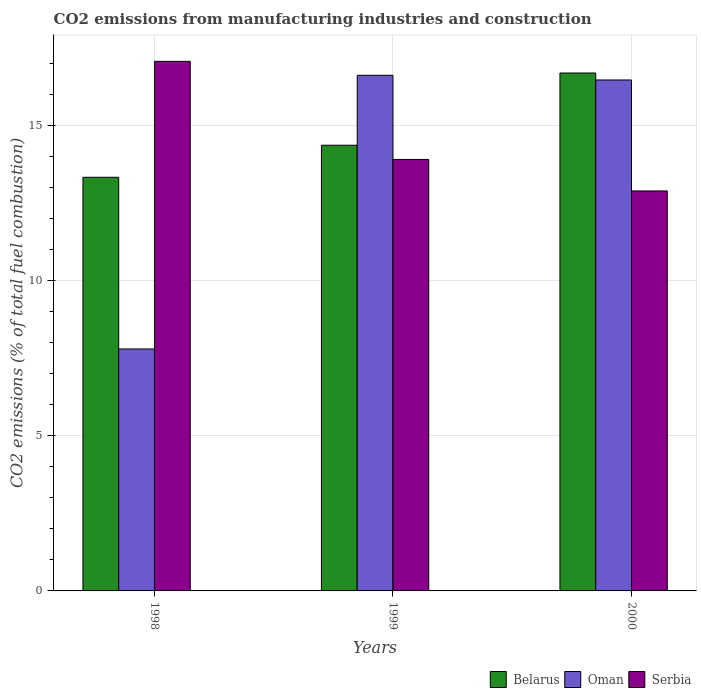How many groups of bars are there?
Provide a short and direct response. 3. Are the number of bars per tick equal to the number of legend labels?
Your answer should be very brief. Yes. How many bars are there on the 1st tick from the right?
Your response must be concise. 3. What is the label of the 2nd group of bars from the left?
Your answer should be compact. 1999. In how many cases, is the number of bars for a given year not equal to the number of legend labels?
Your response must be concise. 0. What is the amount of CO2 emitted in Serbia in 1998?
Provide a succinct answer. 17.07. Across all years, what is the maximum amount of CO2 emitted in Belarus?
Ensure brevity in your answer.  16.69. Across all years, what is the minimum amount of CO2 emitted in Oman?
Provide a short and direct response. 7.8. In which year was the amount of CO2 emitted in Oman maximum?
Provide a short and direct response. 1999. What is the total amount of CO2 emitted in Serbia in the graph?
Your response must be concise. 43.87. What is the difference between the amount of CO2 emitted in Belarus in 1998 and that in 1999?
Your response must be concise. -1.03. What is the difference between the amount of CO2 emitted in Oman in 1998 and the amount of CO2 emitted in Belarus in 1999?
Your response must be concise. -6.57. What is the average amount of CO2 emitted in Oman per year?
Your answer should be very brief. 13.63. In the year 1998, what is the difference between the amount of CO2 emitted in Belarus and amount of CO2 emitted in Serbia?
Offer a terse response. -3.74. What is the ratio of the amount of CO2 emitted in Serbia in 1998 to that in 2000?
Your response must be concise. 1.32. Is the amount of CO2 emitted in Serbia in 1998 less than that in 1999?
Your answer should be compact. No. What is the difference between the highest and the second highest amount of CO2 emitted in Belarus?
Offer a very short reply. 2.33. What is the difference between the highest and the lowest amount of CO2 emitted in Oman?
Offer a terse response. 8.82. Is the sum of the amount of CO2 emitted in Serbia in 1998 and 2000 greater than the maximum amount of CO2 emitted in Oman across all years?
Keep it short and to the point. Yes. What does the 2nd bar from the left in 1998 represents?
Your answer should be very brief. Oman. What does the 3rd bar from the right in 1999 represents?
Provide a succinct answer. Belarus. Is it the case that in every year, the sum of the amount of CO2 emitted in Serbia and amount of CO2 emitted in Oman is greater than the amount of CO2 emitted in Belarus?
Offer a terse response. Yes. How many bars are there?
Keep it short and to the point. 9. How many years are there in the graph?
Give a very brief answer. 3. Are the values on the major ticks of Y-axis written in scientific E-notation?
Offer a terse response. No. Does the graph contain any zero values?
Offer a very short reply. No. Where does the legend appear in the graph?
Keep it short and to the point. Bottom right. How many legend labels are there?
Offer a very short reply. 3. What is the title of the graph?
Give a very brief answer. CO2 emissions from manufacturing industries and construction. What is the label or title of the X-axis?
Ensure brevity in your answer.  Years. What is the label or title of the Y-axis?
Your answer should be very brief. CO2 emissions (% of total fuel combustion). What is the CO2 emissions (% of total fuel combustion) in Belarus in 1998?
Make the answer very short. 13.33. What is the CO2 emissions (% of total fuel combustion) in Oman in 1998?
Offer a terse response. 7.8. What is the CO2 emissions (% of total fuel combustion) of Serbia in 1998?
Offer a terse response. 17.07. What is the CO2 emissions (% of total fuel combustion) of Belarus in 1999?
Your answer should be very brief. 14.36. What is the CO2 emissions (% of total fuel combustion) of Oman in 1999?
Make the answer very short. 16.62. What is the CO2 emissions (% of total fuel combustion) of Serbia in 1999?
Your answer should be very brief. 13.91. What is the CO2 emissions (% of total fuel combustion) in Belarus in 2000?
Your answer should be very brief. 16.69. What is the CO2 emissions (% of total fuel combustion) of Oman in 2000?
Your answer should be very brief. 16.47. What is the CO2 emissions (% of total fuel combustion) of Serbia in 2000?
Provide a succinct answer. 12.89. Across all years, what is the maximum CO2 emissions (% of total fuel combustion) of Belarus?
Provide a succinct answer. 16.69. Across all years, what is the maximum CO2 emissions (% of total fuel combustion) in Oman?
Your answer should be very brief. 16.62. Across all years, what is the maximum CO2 emissions (% of total fuel combustion) in Serbia?
Give a very brief answer. 17.07. Across all years, what is the minimum CO2 emissions (% of total fuel combustion) in Belarus?
Your answer should be very brief. 13.33. Across all years, what is the minimum CO2 emissions (% of total fuel combustion) in Oman?
Provide a succinct answer. 7.8. Across all years, what is the minimum CO2 emissions (% of total fuel combustion) of Serbia?
Offer a very short reply. 12.89. What is the total CO2 emissions (% of total fuel combustion) of Belarus in the graph?
Your answer should be very brief. 44.39. What is the total CO2 emissions (% of total fuel combustion) in Oman in the graph?
Offer a terse response. 40.88. What is the total CO2 emissions (% of total fuel combustion) in Serbia in the graph?
Offer a very short reply. 43.87. What is the difference between the CO2 emissions (% of total fuel combustion) in Belarus in 1998 and that in 1999?
Your answer should be very brief. -1.03. What is the difference between the CO2 emissions (% of total fuel combustion) of Oman in 1998 and that in 1999?
Ensure brevity in your answer.  -8.82. What is the difference between the CO2 emissions (% of total fuel combustion) of Serbia in 1998 and that in 1999?
Your answer should be very brief. 3.16. What is the difference between the CO2 emissions (% of total fuel combustion) in Belarus in 1998 and that in 2000?
Provide a short and direct response. -3.36. What is the difference between the CO2 emissions (% of total fuel combustion) in Oman in 1998 and that in 2000?
Offer a very short reply. -8.67. What is the difference between the CO2 emissions (% of total fuel combustion) of Serbia in 1998 and that in 2000?
Your answer should be compact. 4.18. What is the difference between the CO2 emissions (% of total fuel combustion) in Belarus in 1999 and that in 2000?
Ensure brevity in your answer.  -2.33. What is the difference between the CO2 emissions (% of total fuel combustion) in Oman in 1999 and that in 2000?
Give a very brief answer. 0.15. What is the difference between the CO2 emissions (% of total fuel combustion) in Serbia in 1999 and that in 2000?
Provide a succinct answer. 1.02. What is the difference between the CO2 emissions (% of total fuel combustion) of Belarus in 1998 and the CO2 emissions (% of total fuel combustion) of Oman in 1999?
Provide a succinct answer. -3.29. What is the difference between the CO2 emissions (% of total fuel combustion) of Belarus in 1998 and the CO2 emissions (% of total fuel combustion) of Serbia in 1999?
Your answer should be very brief. -0.58. What is the difference between the CO2 emissions (% of total fuel combustion) in Oman in 1998 and the CO2 emissions (% of total fuel combustion) in Serbia in 1999?
Give a very brief answer. -6.11. What is the difference between the CO2 emissions (% of total fuel combustion) of Belarus in 1998 and the CO2 emissions (% of total fuel combustion) of Oman in 2000?
Offer a very short reply. -3.14. What is the difference between the CO2 emissions (% of total fuel combustion) in Belarus in 1998 and the CO2 emissions (% of total fuel combustion) in Serbia in 2000?
Ensure brevity in your answer.  0.44. What is the difference between the CO2 emissions (% of total fuel combustion) in Oman in 1998 and the CO2 emissions (% of total fuel combustion) in Serbia in 2000?
Offer a terse response. -5.09. What is the difference between the CO2 emissions (% of total fuel combustion) of Belarus in 1999 and the CO2 emissions (% of total fuel combustion) of Oman in 2000?
Offer a terse response. -2.1. What is the difference between the CO2 emissions (% of total fuel combustion) in Belarus in 1999 and the CO2 emissions (% of total fuel combustion) in Serbia in 2000?
Provide a short and direct response. 1.47. What is the difference between the CO2 emissions (% of total fuel combustion) in Oman in 1999 and the CO2 emissions (% of total fuel combustion) in Serbia in 2000?
Your answer should be compact. 3.73. What is the average CO2 emissions (% of total fuel combustion) in Belarus per year?
Offer a terse response. 14.8. What is the average CO2 emissions (% of total fuel combustion) of Oman per year?
Ensure brevity in your answer.  13.63. What is the average CO2 emissions (% of total fuel combustion) of Serbia per year?
Your answer should be compact. 14.62. In the year 1998, what is the difference between the CO2 emissions (% of total fuel combustion) in Belarus and CO2 emissions (% of total fuel combustion) in Oman?
Ensure brevity in your answer.  5.53. In the year 1998, what is the difference between the CO2 emissions (% of total fuel combustion) in Belarus and CO2 emissions (% of total fuel combustion) in Serbia?
Ensure brevity in your answer.  -3.74. In the year 1998, what is the difference between the CO2 emissions (% of total fuel combustion) in Oman and CO2 emissions (% of total fuel combustion) in Serbia?
Your response must be concise. -9.27. In the year 1999, what is the difference between the CO2 emissions (% of total fuel combustion) in Belarus and CO2 emissions (% of total fuel combustion) in Oman?
Provide a succinct answer. -2.25. In the year 1999, what is the difference between the CO2 emissions (% of total fuel combustion) in Belarus and CO2 emissions (% of total fuel combustion) in Serbia?
Offer a very short reply. 0.46. In the year 1999, what is the difference between the CO2 emissions (% of total fuel combustion) in Oman and CO2 emissions (% of total fuel combustion) in Serbia?
Offer a very short reply. 2.71. In the year 2000, what is the difference between the CO2 emissions (% of total fuel combustion) of Belarus and CO2 emissions (% of total fuel combustion) of Oman?
Your answer should be compact. 0.22. In the year 2000, what is the difference between the CO2 emissions (% of total fuel combustion) in Belarus and CO2 emissions (% of total fuel combustion) in Serbia?
Give a very brief answer. 3.8. In the year 2000, what is the difference between the CO2 emissions (% of total fuel combustion) in Oman and CO2 emissions (% of total fuel combustion) in Serbia?
Give a very brief answer. 3.58. What is the ratio of the CO2 emissions (% of total fuel combustion) of Belarus in 1998 to that in 1999?
Give a very brief answer. 0.93. What is the ratio of the CO2 emissions (% of total fuel combustion) in Oman in 1998 to that in 1999?
Provide a succinct answer. 0.47. What is the ratio of the CO2 emissions (% of total fuel combustion) in Serbia in 1998 to that in 1999?
Your answer should be very brief. 1.23. What is the ratio of the CO2 emissions (% of total fuel combustion) in Belarus in 1998 to that in 2000?
Offer a terse response. 0.8. What is the ratio of the CO2 emissions (% of total fuel combustion) in Oman in 1998 to that in 2000?
Your response must be concise. 0.47. What is the ratio of the CO2 emissions (% of total fuel combustion) of Serbia in 1998 to that in 2000?
Ensure brevity in your answer.  1.32. What is the ratio of the CO2 emissions (% of total fuel combustion) in Belarus in 1999 to that in 2000?
Offer a terse response. 0.86. What is the ratio of the CO2 emissions (% of total fuel combustion) of Oman in 1999 to that in 2000?
Your answer should be compact. 1.01. What is the ratio of the CO2 emissions (% of total fuel combustion) of Serbia in 1999 to that in 2000?
Give a very brief answer. 1.08. What is the difference between the highest and the second highest CO2 emissions (% of total fuel combustion) in Belarus?
Offer a very short reply. 2.33. What is the difference between the highest and the second highest CO2 emissions (% of total fuel combustion) of Oman?
Keep it short and to the point. 0.15. What is the difference between the highest and the second highest CO2 emissions (% of total fuel combustion) of Serbia?
Your answer should be compact. 3.16. What is the difference between the highest and the lowest CO2 emissions (% of total fuel combustion) of Belarus?
Provide a short and direct response. 3.36. What is the difference between the highest and the lowest CO2 emissions (% of total fuel combustion) of Oman?
Offer a very short reply. 8.82. What is the difference between the highest and the lowest CO2 emissions (% of total fuel combustion) in Serbia?
Offer a very short reply. 4.18. 